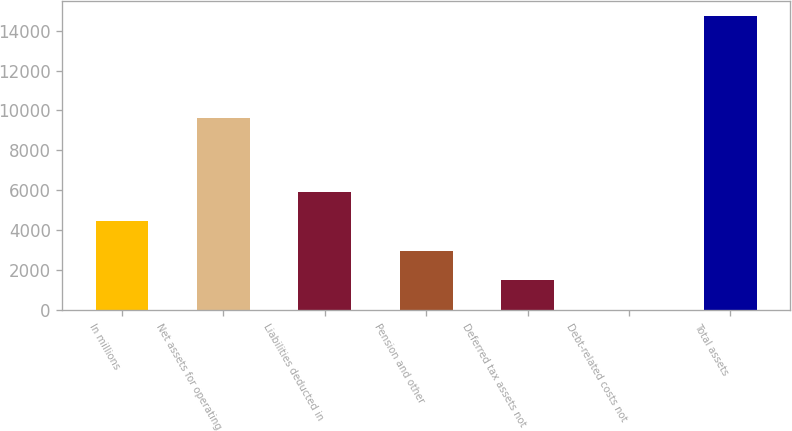Convert chart to OTSL. <chart><loc_0><loc_0><loc_500><loc_500><bar_chart><fcel>In millions<fcel>Net assets for operating<fcel>Liabilities deducted in<fcel>Pension and other<fcel>Deferred tax assets not<fcel>Debt-related costs not<fcel>Total assets<nl><fcel>4441.5<fcel>9646<fcel>5911<fcel>2972<fcel>1502.5<fcel>33<fcel>14728<nl></chart> 